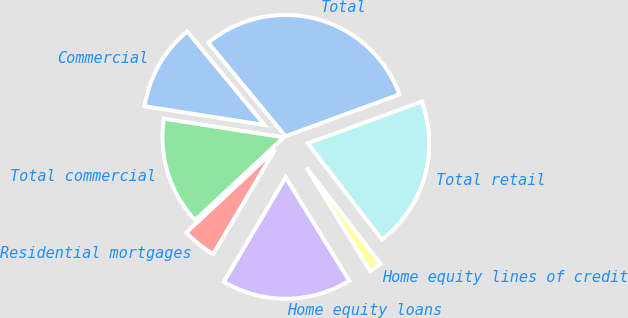Convert chart to OTSL. <chart><loc_0><loc_0><loc_500><loc_500><pie_chart><fcel>Commercial<fcel>Total commercial<fcel>Residential mortgages<fcel>Home equity loans<fcel>Home equity lines of credit<fcel>Total retail<fcel>Total<nl><fcel>11.55%<fcel>14.42%<fcel>4.53%<fcel>17.29%<fcel>1.66%<fcel>20.16%<fcel>30.38%<nl></chart> 